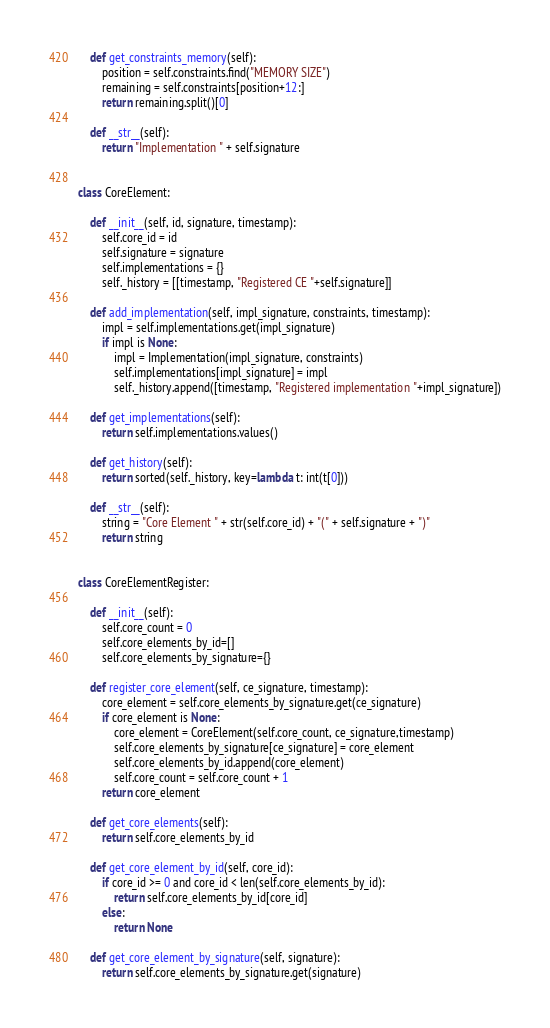Convert code to text. <code><loc_0><loc_0><loc_500><loc_500><_Python_>    def get_constraints_memory(self):
        position = self.constraints.find("MEMORY SIZE")
        remaining = self.constraints[position+12:]
        return remaining.split()[0]

    def __str__(self):
        return "Implementation " + self.signature


class CoreElement:

    def __init__(self, id, signature, timestamp):
        self.core_id = id
        self.signature = signature
        self.implementations = {}
        self._history = [[timestamp, "Registered CE "+self.signature]]

    def add_implementation(self, impl_signature, constraints, timestamp):
        impl = self.implementations.get(impl_signature)
        if impl is None:
            impl = Implementation(impl_signature, constraints)
            self.implementations[impl_signature] = impl
            self._history.append([timestamp, "Registered implementation "+impl_signature])
    
    def get_implementations(self):
        return self.implementations.values()

    def get_history(self):
        return sorted(self._history, key=lambda t: int(t[0]))

    def __str__(self):
        string = "Core Element " + str(self.core_id) + "(" + self.signature + ")"
        return string


class CoreElementRegister:

    def __init__(self):
        self.core_count = 0
        self.core_elements_by_id=[]
        self.core_elements_by_signature={}

    def register_core_element(self, ce_signature, timestamp):
        core_element = self.core_elements_by_signature.get(ce_signature)
        if core_element is None:
            core_element = CoreElement(self.core_count, ce_signature,timestamp)
            self.core_elements_by_signature[ce_signature] = core_element
            self.core_elements_by_id.append(core_element)
            self.core_count = self.core_count + 1
        return core_element

    def get_core_elements(self):
        return self.core_elements_by_id

    def get_core_element_by_id(self, core_id):
        if core_id >= 0 and core_id < len(self.core_elements_by_id):
            return self.core_elements_by_id[core_id]
        else:
            return None

    def get_core_element_by_signature(self, signature):
        return self.core_elements_by_signature.get(signature)
</code> 